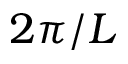Convert formula to latex. <formula><loc_0><loc_0><loc_500><loc_500>2 \pi / L</formula> 